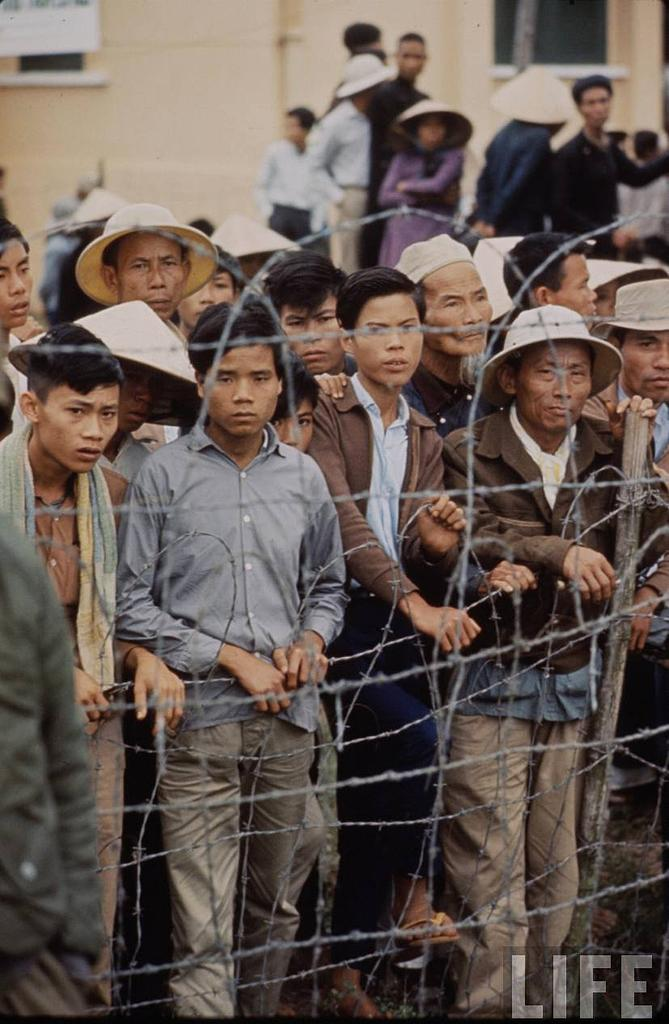What is located in the center of the image? There is a fence in the center of the image. What can be seen behind the fence? There are persons standing behind the fence. What is visible in the background of the image? There is a building and a window visible in the background of the image. What type of dress is the aunt wearing in the image? There is no aunt present in the image, so it is not possible to answer that question about her dress. 